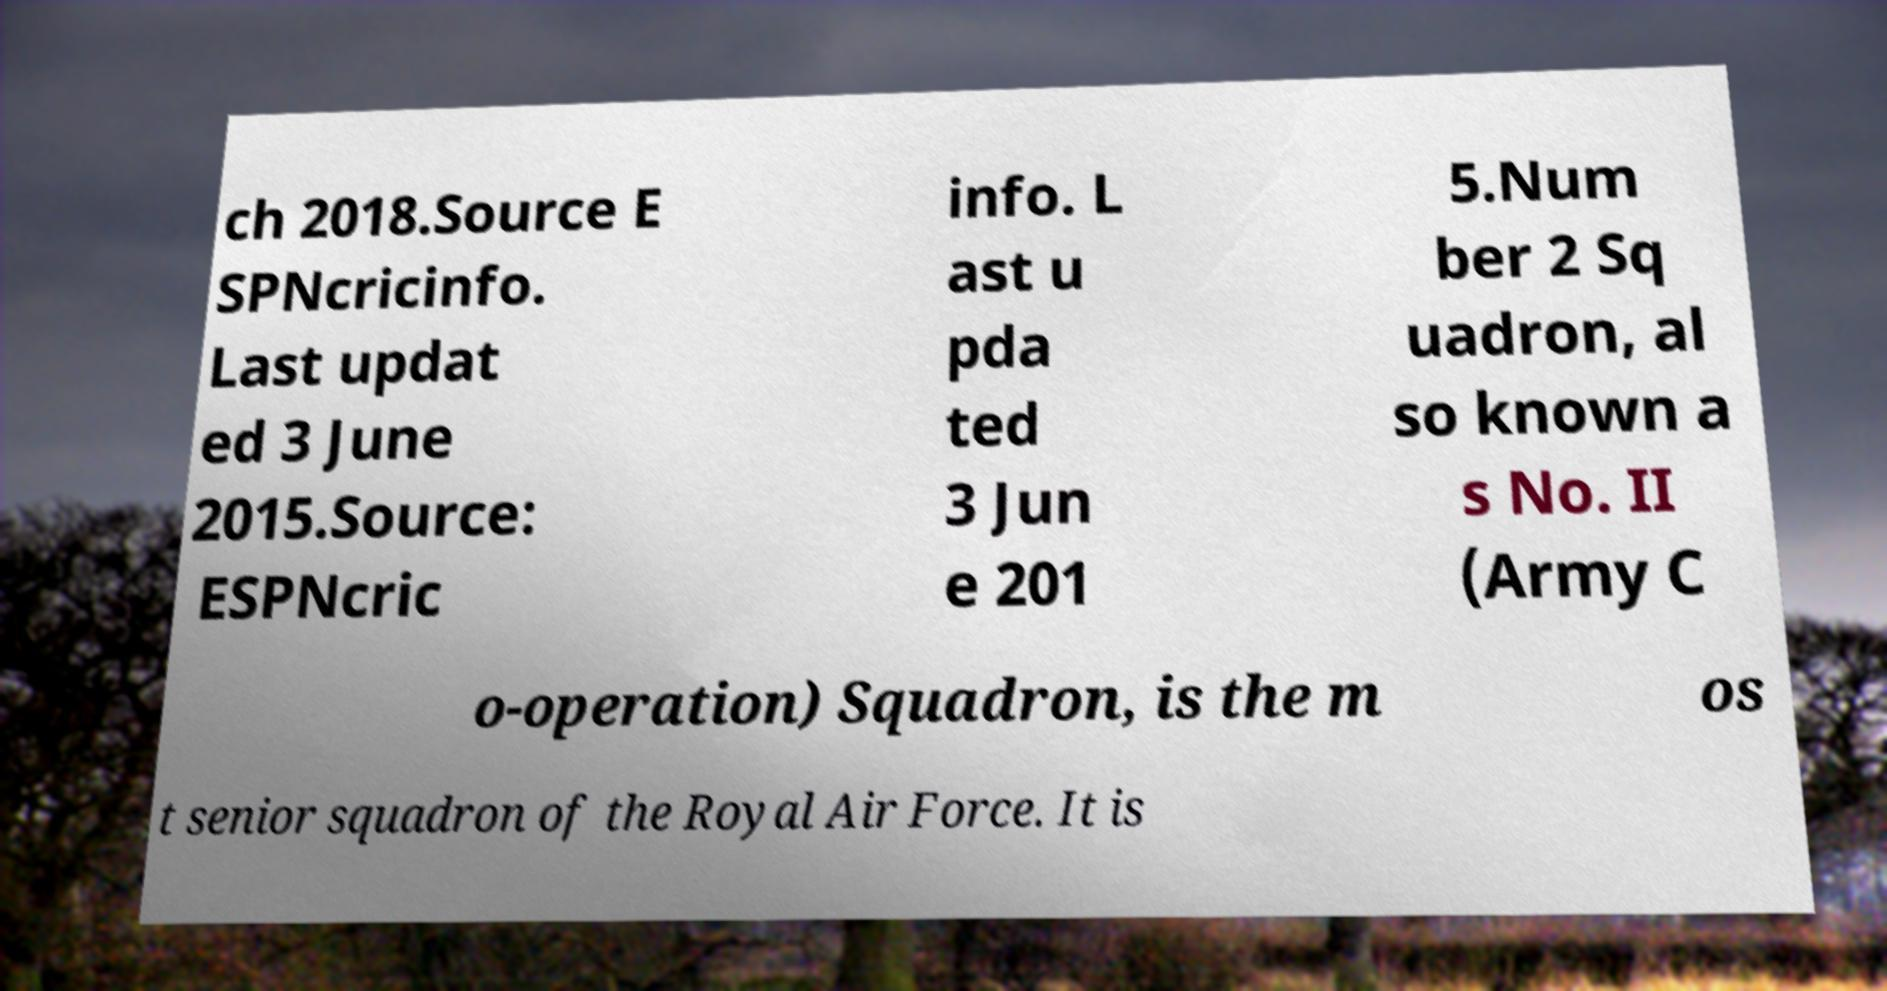Could you extract and type out the text from this image? ch 2018.Source E SPNcricinfo. Last updat ed 3 June 2015.Source: ESPNcric info. L ast u pda ted 3 Jun e 201 5.Num ber 2 Sq uadron, al so known a s No. II (Army C o-operation) Squadron, is the m os t senior squadron of the Royal Air Force. It is 